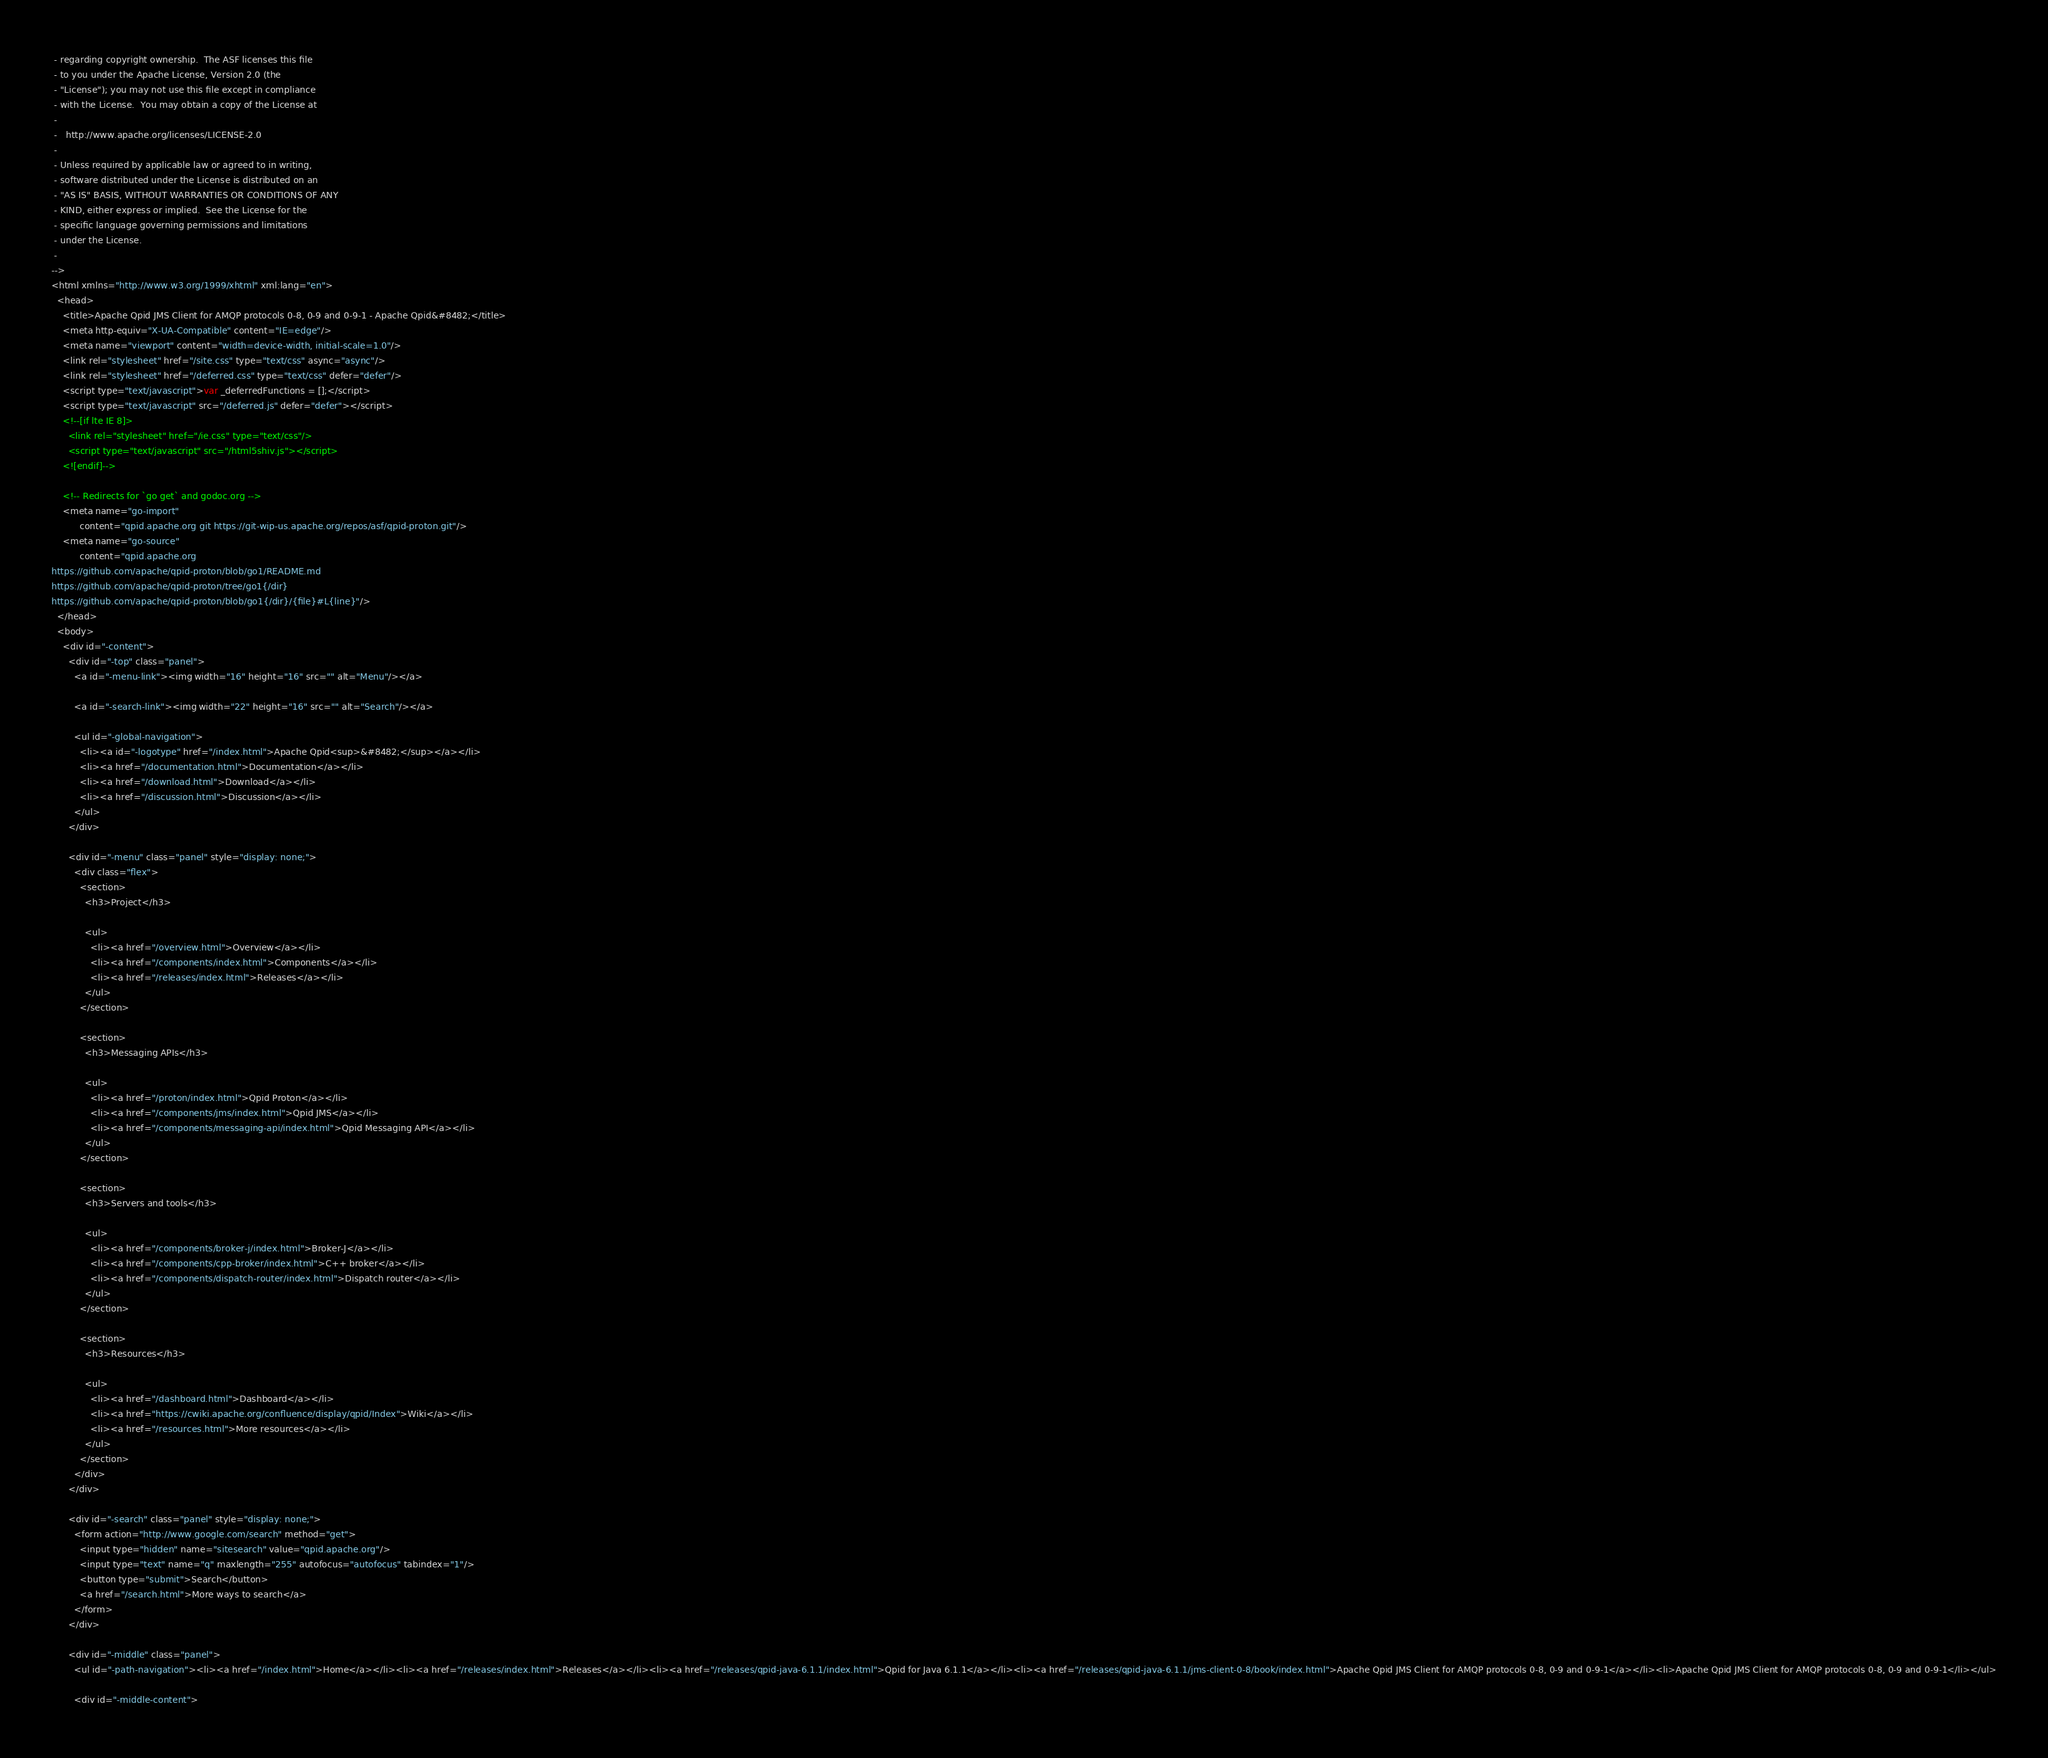Convert code to text. <code><loc_0><loc_0><loc_500><loc_500><_HTML_> - regarding copyright ownership.  The ASF licenses this file
 - to you under the Apache License, Version 2.0 (the
 - "License"); you may not use this file except in compliance
 - with the License.  You may obtain a copy of the License at
 -
 -   http://www.apache.org/licenses/LICENSE-2.0
 -
 - Unless required by applicable law or agreed to in writing,
 - software distributed under the License is distributed on an
 - "AS IS" BASIS, WITHOUT WARRANTIES OR CONDITIONS OF ANY
 - KIND, either express or implied.  See the License for the
 - specific language governing permissions and limitations
 - under the License.
 -
-->
<html xmlns="http://www.w3.org/1999/xhtml" xml:lang="en">
  <head>
    <title>Apache Qpid JMS Client for AMQP protocols 0-8, 0-9 and 0-9-1 - Apache Qpid&#8482;</title>
    <meta http-equiv="X-UA-Compatible" content="IE=edge"/>
    <meta name="viewport" content="width=device-width, initial-scale=1.0"/>
    <link rel="stylesheet" href="/site.css" type="text/css" async="async"/>
    <link rel="stylesheet" href="/deferred.css" type="text/css" defer="defer"/>
    <script type="text/javascript">var _deferredFunctions = [];</script>
    <script type="text/javascript" src="/deferred.js" defer="defer"></script>
    <!--[if lte IE 8]>
      <link rel="stylesheet" href="/ie.css" type="text/css"/>
      <script type="text/javascript" src="/html5shiv.js"></script>
    <![endif]-->

    <!-- Redirects for `go get` and godoc.org -->
    <meta name="go-import"
          content="qpid.apache.org git https://git-wip-us.apache.org/repos/asf/qpid-proton.git"/>
    <meta name="go-source"
          content="qpid.apache.org
https://github.com/apache/qpid-proton/blob/go1/README.md
https://github.com/apache/qpid-proton/tree/go1{/dir}
https://github.com/apache/qpid-proton/blob/go1{/dir}/{file}#L{line}"/>
  </head>
  <body>
    <div id="-content">
      <div id="-top" class="panel">
        <a id="-menu-link"><img width="16" height="16" src="" alt="Menu"/></a>

        <a id="-search-link"><img width="22" height="16" src="" alt="Search"/></a>

        <ul id="-global-navigation">
          <li><a id="-logotype" href="/index.html">Apache Qpid<sup>&#8482;</sup></a></li>
          <li><a href="/documentation.html">Documentation</a></li>
          <li><a href="/download.html">Download</a></li>
          <li><a href="/discussion.html">Discussion</a></li>
        </ul>
      </div>

      <div id="-menu" class="panel" style="display: none;">
        <div class="flex">
          <section>
            <h3>Project</h3>

            <ul>
              <li><a href="/overview.html">Overview</a></li>
              <li><a href="/components/index.html">Components</a></li>
              <li><a href="/releases/index.html">Releases</a></li>
            </ul>
          </section>

          <section>
            <h3>Messaging APIs</h3>

            <ul>
              <li><a href="/proton/index.html">Qpid Proton</a></li>
              <li><a href="/components/jms/index.html">Qpid JMS</a></li>
              <li><a href="/components/messaging-api/index.html">Qpid Messaging API</a></li>
            </ul>
          </section>

          <section>
            <h3>Servers and tools</h3>

            <ul>
              <li><a href="/components/broker-j/index.html">Broker-J</a></li>
              <li><a href="/components/cpp-broker/index.html">C++ broker</a></li>
              <li><a href="/components/dispatch-router/index.html">Dispatch router</a></li>
            </ul>
          </section>

          <section>
            <h3>Resources</h3>

            <ul>
              <li><a href="/dashboard.html">Dashboard</a></li>
              <li><a href="https://cwiki.apache.org/confluence/display/qpid/Index">Wiki</a></li>
              <li><a href="/resources.html">More resources</a></li>
            </ul>
          </section>
        </div>
      </div>

      <div id="-search" class="panel" style="display: none;">
        <form action="http://www.google.com/search" method="get">
          <input type="hidden" name="sitesearch" value="qpid.apache.org"/>
          <input type="text" name="q" maxlength="255" autofocus="autofocus" tabindex="1"/>
          <button type="submit">Search</button>
          <a href="/search.html">More ways to search</a>
        </form>
      </div>

      <div id="-middle" class="panel">
        <ul id="-path-navigation"><li><a href="/index.html">Home</a></li><li><a href="/releases/index.html">Releases</a></li><li><a href="/releases/qpid-java-6.1.1/index.html">Qpid for Java 6.1.1</a></li><li><a href="/releases/qpid-java-6.1.1/jms-client-0-8/book/index.html">Apache Qpid JMS Client for AMQP protocols 0-8, 0-9 and 0-9-1</a></li><li>Apache Qpid JMS Client for AMQP protocols 0-8, 0-9 and 0-9-1</li></ul>

        <div id="-middle-content"></code> 